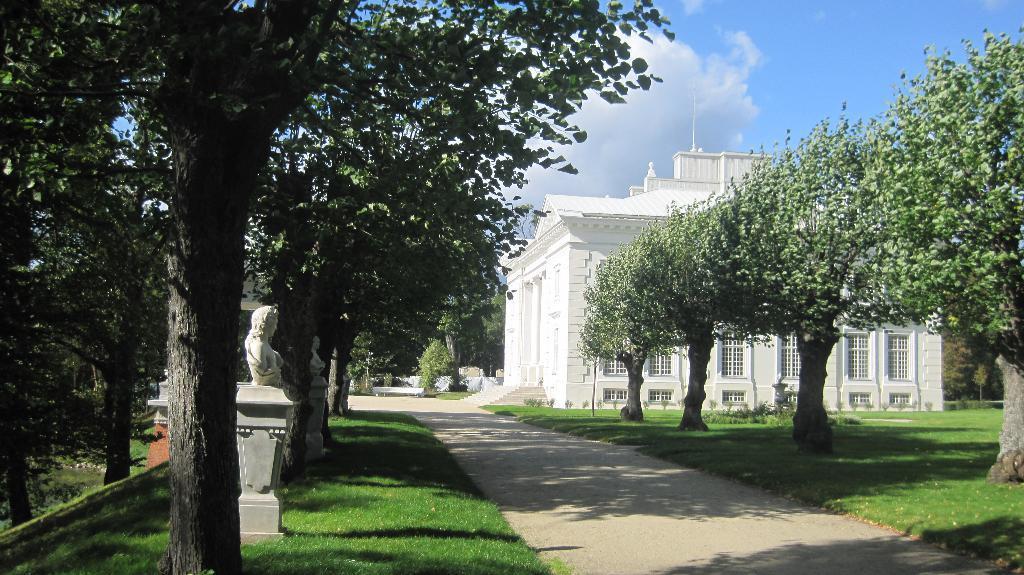How would you summarize this image in a sentence or two? In this picture we see a white house surrounded by green grass and trees. It also has a walking path. Here the sky is blue. 